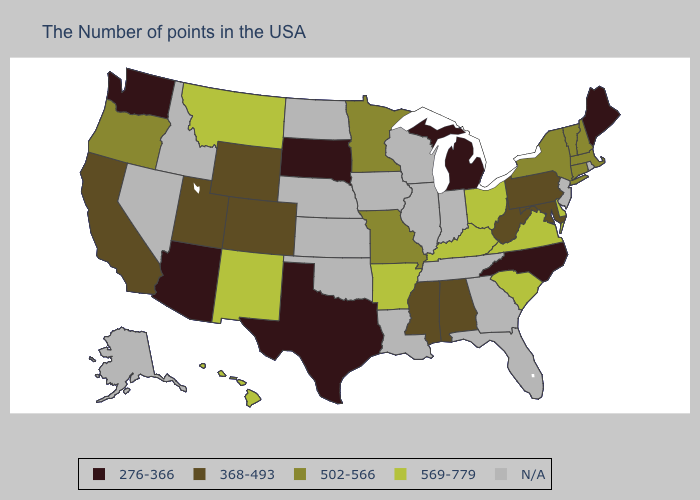What is the value of New Jersey?
Concise answer only. N/A. What is the lowest value in the Northeast?
Answer briefly. 276-366. Is the legend a continuous bar?
Give a very brief answer. No. Does South Dakota have the highest value in the MidWest?
Short answer required. No. Which states have the lowest value in the USA?
Answer briefly. Maine, North Carolina, Michigan, Texas, South Dakota, Arizona, Washington. Does Colorado have the highest value in the USA?
Quick response, please. No. What is the highest value in the USA?
Answer briefly. 569-779. Is the legend a continuous bar?
Answer briefly. No. What is the lowest value in the South?
Concise answer only. 276-366. Name the states that have a value in the range 569-779?
Write a very short answer. Delaware, Virginia, South Carolina, Ohio, Kentucky, Arkansas, New Mexico, Montana, Hawaii. What is the value of Indiana?
Concise answer only. N/A. Among the states that border Georgia , which have the lowest value?
Keep it brief. North Carolina. Among the states that border Georgia , does North Carolina have the highest value?
Be succinct. No. 